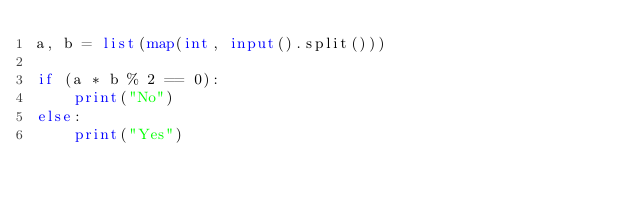Convert code to text. <code><loc_0><loc_0><loc_500><loc_500><_Python_>a, b = list(map(int, input().split()))

if (a * b % 2 == 0):
    print("No")
else:
    print("Yes")
</code> 